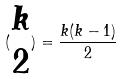Convert formula to latex. <formula><loc_0><loc_0><loc_500><loc_500>( \begin{matrix} k \\ 2 \end{matrix} ) = \frac { k ( k - 1 ) } { 2 }</formula> 